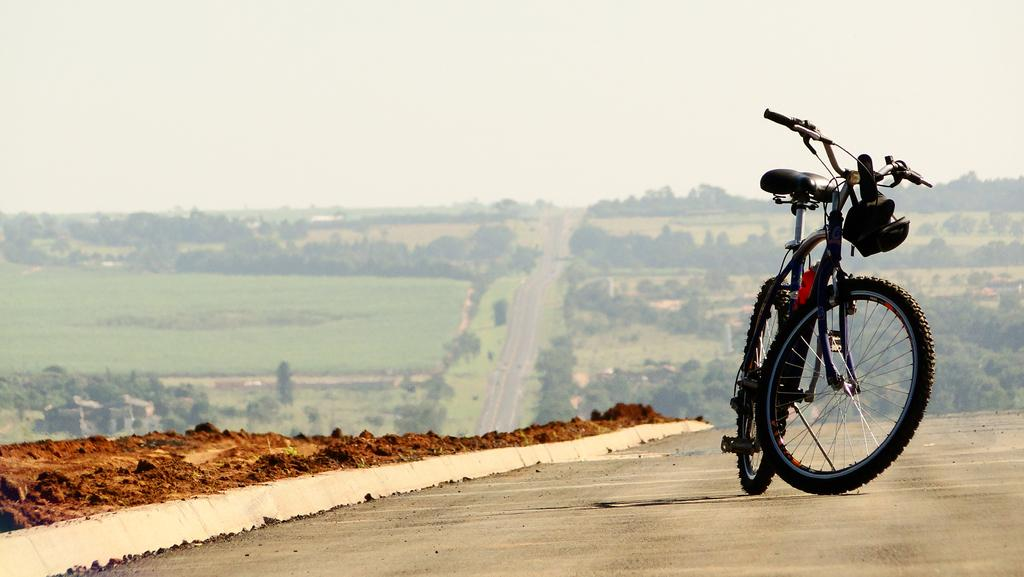What is the main object on the road in the image? There is a bicycle on the road in the image. What can be seen in the middle of the image? There are crops and trees in the middle of the image. What is visible at the top of the image? The sky is visible at the top of the image. How many friends are sitting on the rock in the image? There is no rock or friends present in the image. 